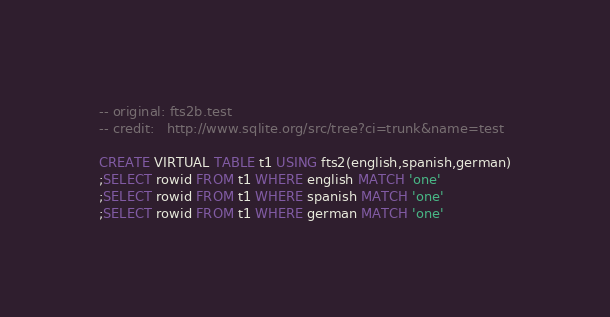Convert code to text. <code><loc_0><loc_0><loc_500><loc_500><_SQL_>-- original: fts2b.test
-- credit:   http://www.sqlite.org/src/tree?ci=trunk&name=test

CREATE VIRTUAL TABLE t1 USING fts2(english,spanish,german)
;SELECT rowid FROM t1 WHERE english MATCH 'one'
;SELECT rowid FROM t1 WHERE spanish MATCH 'one'
;SELECT rowid FROM t1 WHERE german MATCH 'one'</code> 